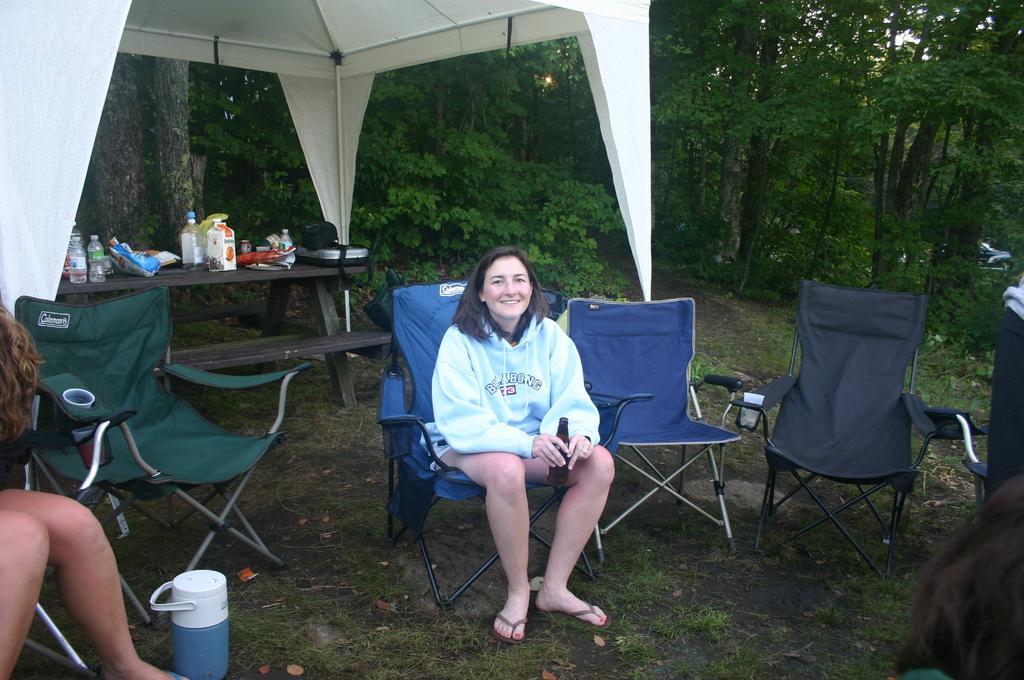Could you give a brief overview of what you see in this image? In this image,There is a ground of grass, There are some chairs and a woman sitting on the chair, In the left side there is a person sitting on the chair, And in the background there are some trees in green color. 